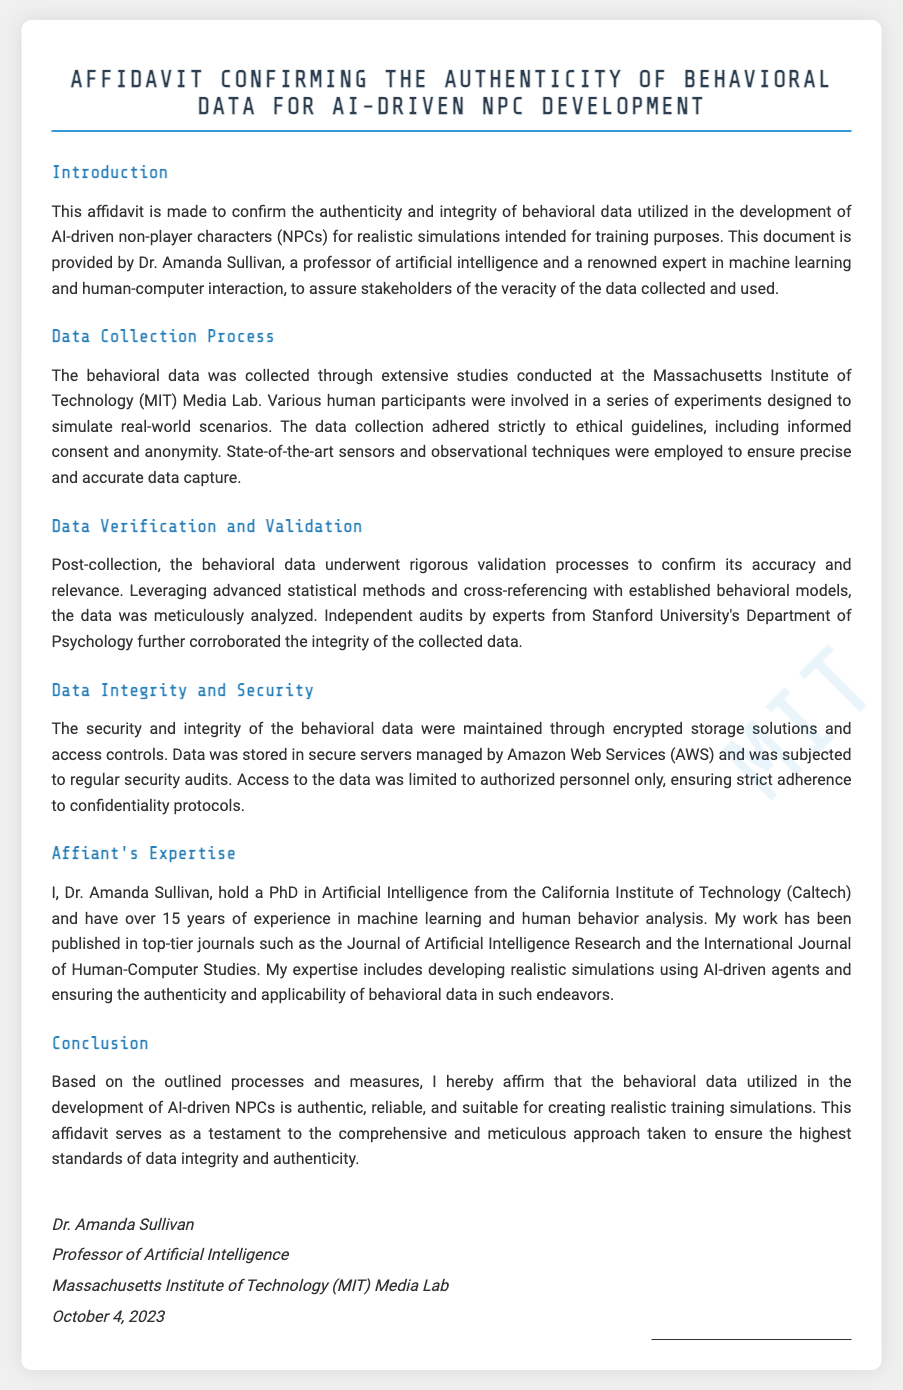What is the purpose of the affidavit? The affidavit confirms the authenticity and integrity of behavioral data utilized for AI-driven NPC development.
Answer: authenticity and integrity Who is the affiant? The affiant is the person who stands as a witness to the affidavit, Dr. Amanda Sullivan.
Answer: Dr. Amanda Sullivan Where was the data collected? The behavioral data was collected at the Massachusetts Institute of Technology (MIT) Media Lab.
Answer: Massachusetts Institute of Technology (MIT) Media Lab What is the date of the affidavit? The affidavit is dated October 4, 2023.
Answer: October 4, 2023 How long has the affiant been working in their field? The affiant, Dr. Amanda Sullivan, has over 15 years of experience in machine learning and human behavior analysis.
Answer: over 15 years Which university conducted independent audits of the data? Independent audits were conducted by experts from Stanford University's Department of Psychology.
Answer: Stanford University What is one ethical guideline followed during data collection? The data collection adhered strictly to ethical guidelines, including informed consent.
Answer: informed consent What kind of data was collected for NPC development? The data collected was behavioral data for AI-driven non-player characters (NPCs).
Answer: behavioral data What kind of technology was used in data collection? State-of-the-art sensors and observational techniques were employed during data collection.
Answer: sensors and observational techniques 